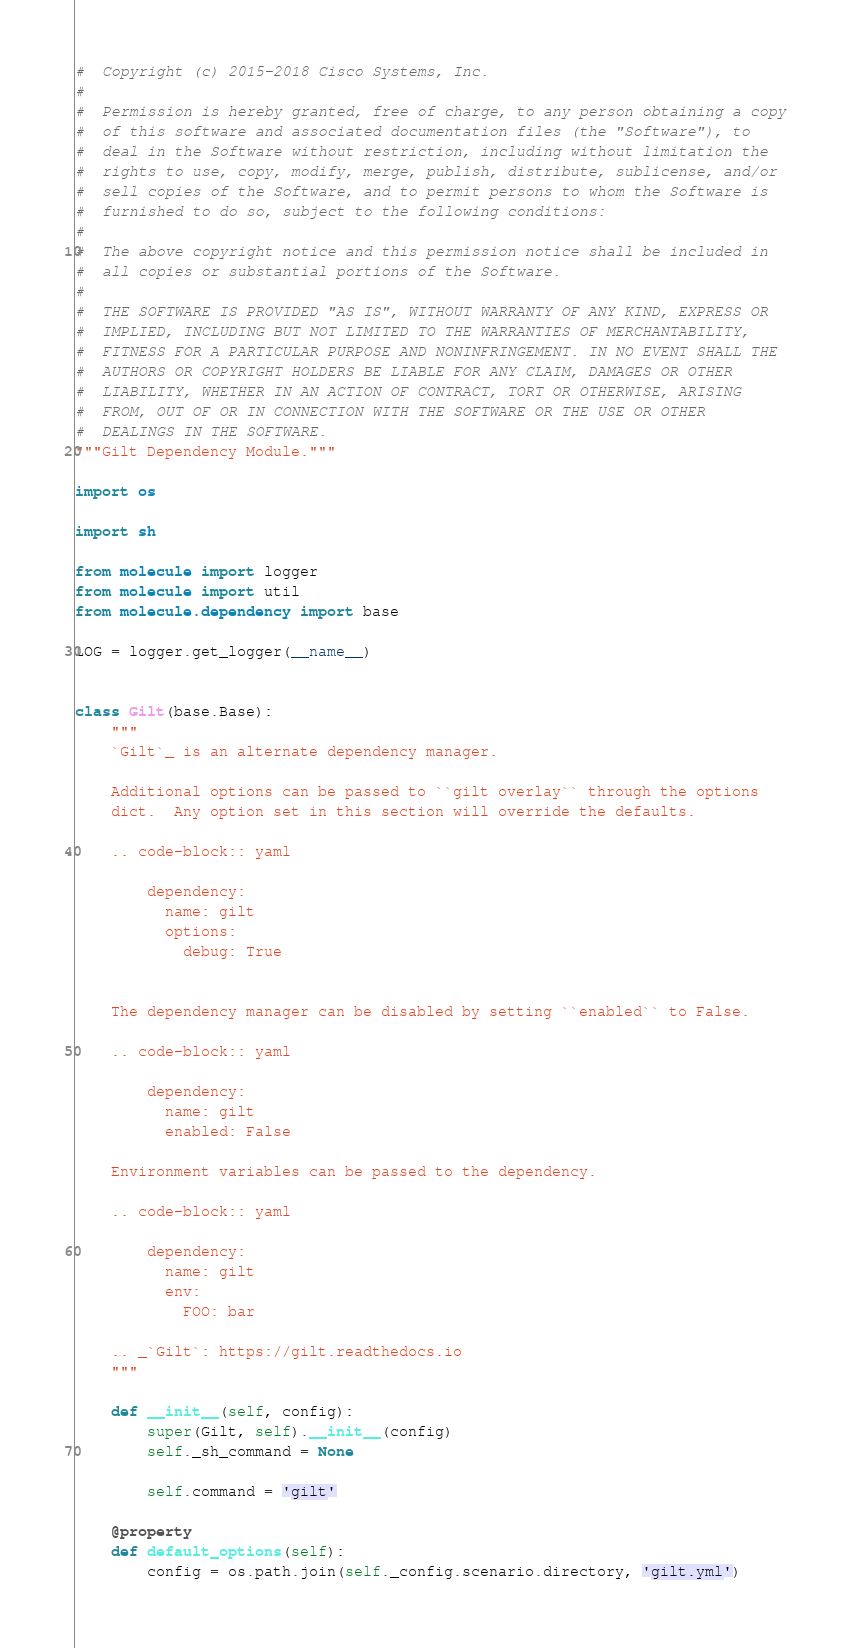<code> <loc_0><loc_0><loc_500><loc_500><_Python_>#  Copyright (c) 2015-2018 Cisco Systems, Inc.
#
#  Permission is hereby granted, free of charge, to any person obtaining a copy
#  of this software and associated documentation files (the "Software"), to
#  deal in the Software without restriction, including without limitation the
#  rights to use, copy, modify, merge, publish, distribute, sublicense, and/or
#  sell copies of the Software, and to permit persons to whom the Software is
#  furnished to do so, subject to the following conditions:
#
#  The above copyright notice and this permission notice shall be included in
#  all copies or substantial portions of the Software.
#
#  THE SOFTWARE IS PROVIDED "AS IS", WITHOUT WARRANTY OF ANY KIND, EXPRESS OR
#  IMPLIED, INCLUDING BUT NOT LIMITED TO THE WARRANTIES OF MERCHANTABILITY,
#  FITNESS FOR A PARTICULAR PURPOSE AND NONINFRINGEMENT. IN NO EVENT SHALL THE
#  AUTHORS OR COPYRIGHT HOLDERS BE LIABLE FOR ANY CLAIM, DAMAGES OR OTHER
#  LIABILITY, WHETHER IN AN ACTION OF CONTRACT, TORT OR OTHERWISE, ARISING
#  FROM, OUT OF OR IN CONNECTION WITH THE SOFTWARE OR THE USE OR OTHER
#  DEALINGS IN THE SOFTWARE.
"""Gilt Dependency Module."""

import os

import sh

from molecule import logger
from molecule import util
from molecule.dependency import base

LOG = logger.get_logger(__name__)


class Gilt(base.Base):
    """
    `Gilt`_ is an alternate dependency manager.

    Additional options can be passed to ``gilt overlay`` through the options
    dict.  Any option set in this section will override the defaults.

    .. code-block:: yaml

        dependency:
          name: gilt
          options:
            debug: True


    The dependency manager can be disabled by setting ``enabled`` to False.

    .. code-block:: yaml

        dependency:
          name: gilt
          enabled: False

    Environment variables can be passed to the dependency.

    .. code-block:: yaml

        dependency:
          name: gilt
          env:
            FOO: bar

    .. _`Gilt`: https://gilt.readthedocs.io
    """

    def __init__(self, config):
        super(Gilt, self).__init__(config)
        self._sh_command = None

        self.command = 'gilt'

    @property
    def default_options(self):
        config = os.path.join(self._config.scenario.directory, 'gilt.yml')</code> 